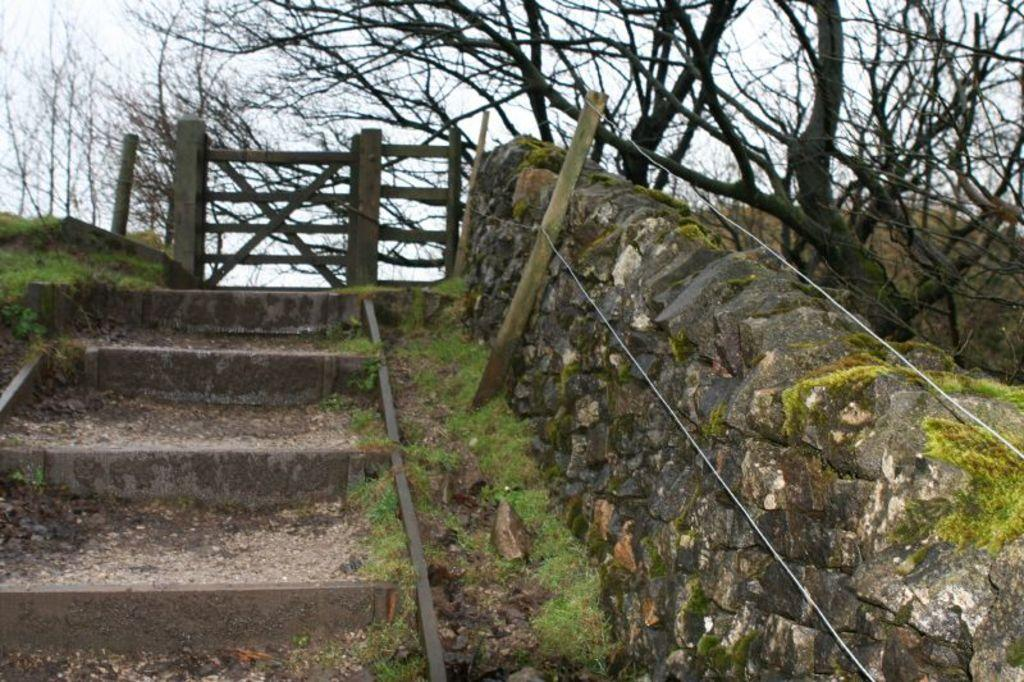What type of structure is present in the image? There are stairs in the image. What can be seen near the stairs? There is a rock wall with wooden fencing in the image. What is visible in the background of the image? There is a dry tree in the background of the image. How many chains are attached to the girl in the image? There is no girl present in the image, so there are no chains attached to her. 